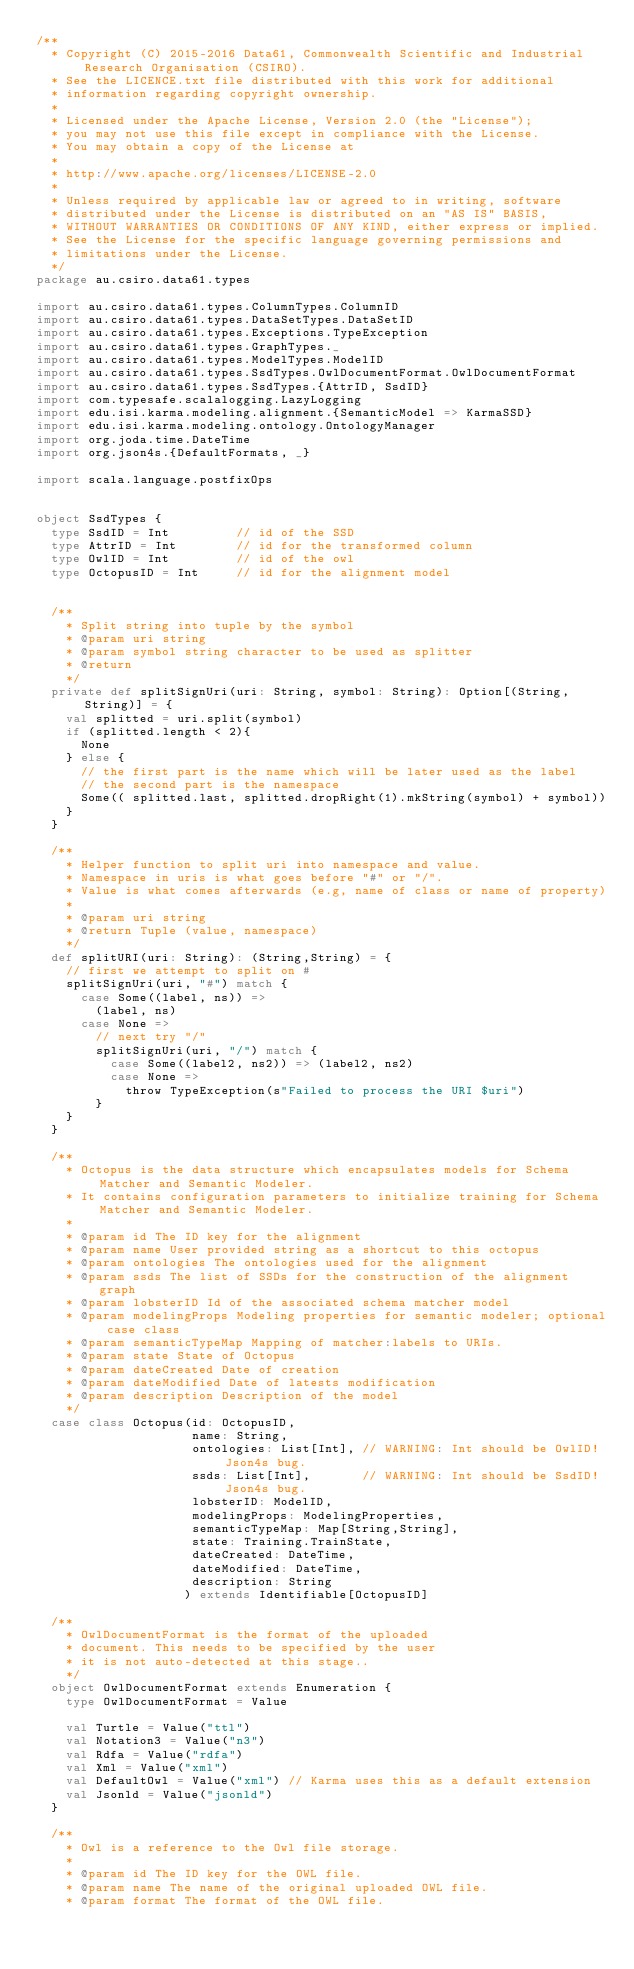Convert code to text. <code><loc_0><loc_0><loc_500><loc_500><_Scala_>/**
  * Copyright (C) 2015-2016 Data61, Commonwealth Scientific and Industrial Research Organisation (CSIRO).
  * See the LICENCE.txt file distributed with this work for additional
  * information regarding copyright ownership.
  *
  * Licensed under the Apache License, Version 2.0 (the "License");
  * you may not use this file except in compliance with the License.
  * You may obtain a copy of the License at
  *
  * http://www.apache.org/licenses/LICENSE-2.0
  *
  * Unless required by applicable law or agreed to in writing, software
  * distributed under the License is distributed on an "AS IS" BASIS,
  * WITHOUT WARRANTIES OR CONDITIONS OF ANY KIND, either express or implied.
  * See the License for the specific language governing permissions and
  * limitations under the License.
  */
package au.csiro.data61.types

import au.csiro.data61.types.ColumnTypes.ColumnID
import au.csiro.data61.types.DataSetTypes.DataSetID
import au.csiro.data61.types.Exceptions.TypeException
import au.csiro.data61.types.GraphTypes._
import au.csiro.data61.types.ModelTypes.ModelID
import au.csiro.data61.types.SsdTypes.OwlDocumentFormat.OwlDocumentFormat
import au.csiro.data61.types.SsdTypes.{AttrID, SsdID}
import com.typesafe.scalalogging.LazyLogging
import edu.isi.karma.modeling.alignment.{SemanticModel => KarmaSSD}
import edu.isi.karma.modeling.ontology.OntologyManager
import org.joda.time.DateTime
import org.json4s.{DefaultFormats, _}

import scala.language.postfixOps


object SsdTypes {
  type SsdID = Int         // id of the SSD
  type AttrID = Int        // id for the transformed column
  type OwlID = Int         // id of the owl
  type OctopusID = Int     // id for the alignment model


  /**
    * Split string into tuple by the symbol
    * @param uri string
    * @param symbol string character to be used as splitter
    * @return
    */
  private def splitSignUri(uri: String, symbol: String): Option[(String,String)] = {
    val splitted = uri.split(symbol)
    if (splitted.length < 2){
      None
    } else {
      // the first part is the name which will be later used as the label
      // the second part is the namespace
      Some(( splitted.last, splitted.dropRight(1).mkString(symbol) + symbol))
    }
  }

  /**
    * Helper function to split uri into namespace and value.
    * Namespace in uris is what goes before "#" or "/".
    * Value is what comes afterwards (e.g, name of class or name of property)
    *
    * @param uri string
    * @return Tuple (value, namespace)
    */
  def splitURI(uri: String): (String,String) = {
    // first we attempt to split on #
    splitSignUri(uri, "#") match {
      case Some((label, ns)) =>
        (label, ns)
      case None =>
        // next try "/"
        splitSignUri(uri, "/") match {
          case Some((label2, ns2)) => (label2, ns2)
          case None =>
            throw TypeException(s"Failed to process the URI $uri")
        }
    }
  }

  /**
    * Octopus is the data structure which encapsulates models for Schema Matcher and Semantic Modeler.
    * It contains configuration parameters to initialize training for Schema Matcher and Semantic Modeler.
    *
    * @param id The ID key for the alignment
    * @param name User provided string as a shortcut to this octopus
    * @param ontologies The ontologies used for the alignment
    * @param ssds The list of SSDs for the construction of the alignment graph
    * @param lobsterID Id of the associated schema matcher model
    * @param modelingProps Modeling properties for semantic modeler; optional case class
    * @param semanticTypeMap Mapping of matcher:labels to URIs.
    * @param state State of Octopus
    * @param dateCreated Date of creation
    * @param dateModified Date of latests modification
    * @param description Description of the model
    */
  case class Octopus(id: OctopusID,
                     name: String,
                     ontologies: List[Int], // WARNING: Int should be OwlID! Json4s bug.
                     ssds: List[Int],       // WARNING: Int should be SsdID! Json4s bug.
                     lobsterID: ModelID,
                     modelingProps: ModelingProperties,
                     semanticTypeMap: Map[String,String],
                     state: Training.TrainState,
                     dateCreated: DateTime,
                     dateModified: DateTime,
                     description: String
                    ) extends Identifiable[OctopusID]

  /**
    * OwlDocumentFormat is the format of the uploaded
    * document. This needs to be specified by the user
    * it is not auto-detected at this stage..
    */
  object OwlDocumentFormat extends Enumeration {
    type OwlDocumentFormat = Value

    val Turtle = Value("ttl")
    val Notation3 = Value("n3")
    val Rdfa = Value("rdfa")
    val Xml = Value("xml")
    val DefaultOwl = Value("xml") // Karma uses this as a default extension
    val Jsonld = Value("jsonld")
  }

  /**
    * Owl is a reference to the Owl file storage.
    *
    * @param id The ID key for the OWL file.
    * @param name The name of the original uploaded OWL file.
    * @param format The format of the OWL file.</code> 